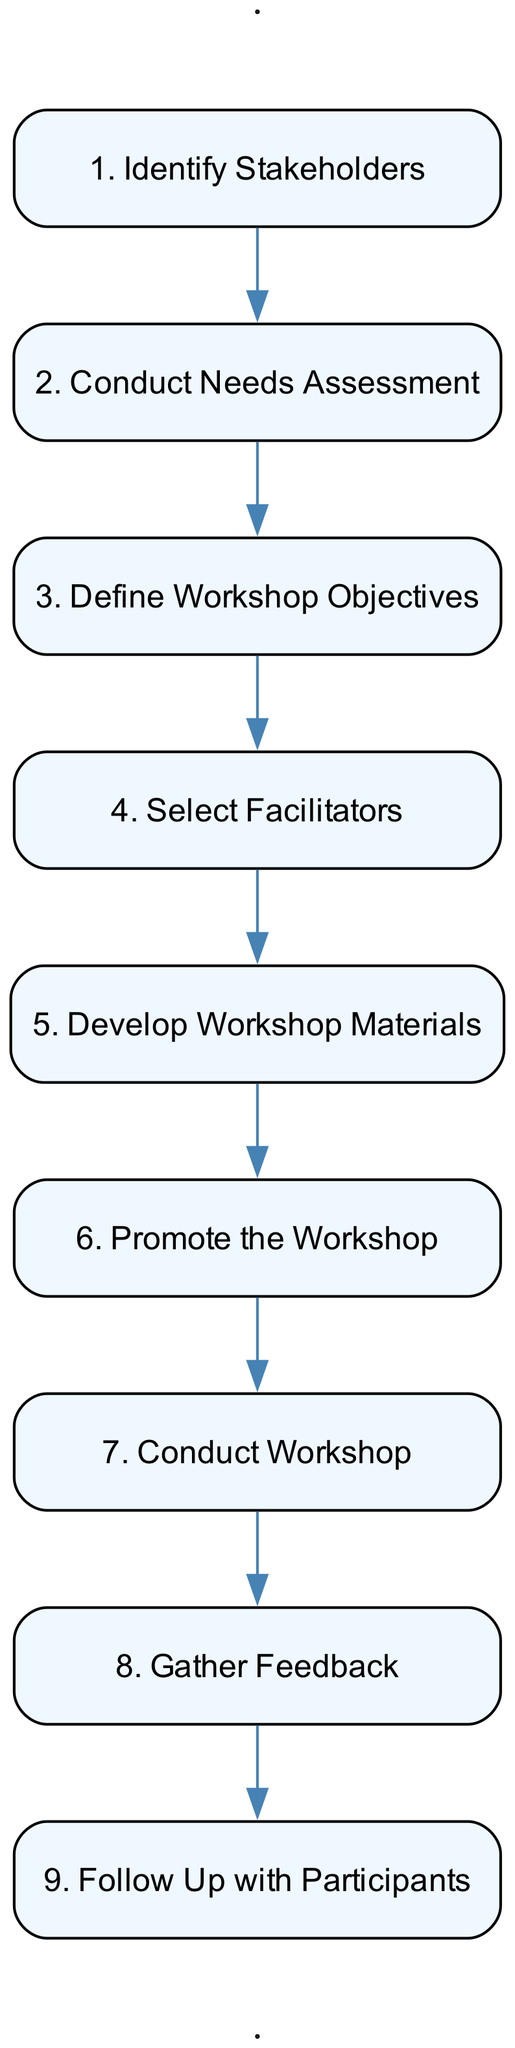What is the first step in the workshop process? The diagram starts with the first node, labeled as "1. Identify Stakeholders". This indicates that identifying stakeholders is the initial action in the sequence.
Answer: Identify Stakeholders How many steps are there in total? By counting the numbered nodes in the diagram, we see there are a total of nine steps. Each step is sequentially numbered from 1 to 9.
Answer: 9 What step comes after "Develop Workshop Materials"? The diagram shows that "Develop Workshop Materials" is the fifth step, and the next step (6th) is "Promote the Workshop". There’s a connection from the fifth node to the sixth in the sequence.
Answer: Promote the Workshop Which step includes feedback collection? The diagram specifically highlights "Gather Feedback" as the step dedicated to collecting evaluations from participants, which is the eighth step in the sequence.
Answer: Gather Feedback What is the last step in the process? The last node in the diagram is labeled "9. Follow Up with Participants", indicating that this is the final action taken after the workshop is conducted.
Answer: Follow Up with Participants What are the steps related to workshop delivery? The steps related to workshop delivery are "Conduct Workshop" (the seventh step) which is directly preceded by "Promote the Workshop" and is critically important for the execution of the workshop activities.
Answer: Conduct Workshop What kind of evaluation is suggested after the workshop? The diagram indicates that the workshop concludes with a feedback collection phase through "Gather Feedback", suggesting evaluations of the workshop’s effectiveness.
Answer: Gather Feedback Which two steps focus on preparation before the workshop? The first two steps are "Identify Stakeholders" and "Conduct Needs Assessment", which focus on the preparation and understanding of needs before the actual workshop can be organized.
Answer: Identify Stakeholders and Conduct Needs Assessment What is the purpose of the "Define Workshop Objectives" step? The step labeled "Define Workshop Objectives" signifies setting clear goals for the workshop to enhance awareness and understanding of gender equality issues.
Answer: Set clear goals 